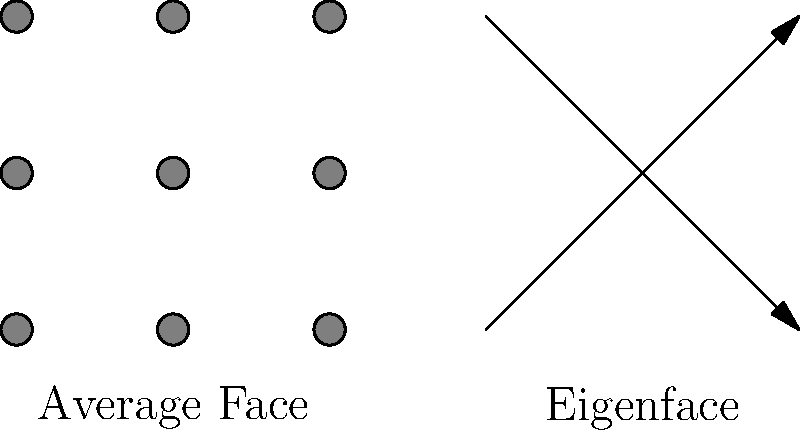In facial recognition using Principal Component Analysis (PCA), what does the eigenface represent in relation to the average face? To understand the concept of eigenfaces in facial recognition using PCA, let's break it down step-by-step:

1. Average Face:
   - The average face is computed by taking the mean of all face images in the dataset.
   - It represents the "typical" face and serves as a baseline for comparison.

2. PCA:
   - PCA is applied to the dataset of face images to find the principal components.
   - These components capture the most significant variations in the dataset.

3. Eigenfaces:
   - Eigenfaces are the eigenvectors of the covariance matrix of the face image dataset.
   - Each eigenface represents a direction of variation from the average face.
   - They are ordered by their corresponding eigenvalues, which indicate the amount of variance they capture.

4. Interpretation:
   - Eigenfaces can be thought of as the "building blocks" of faces.
   - They represent the most common ways in which faces in the dataset differ from the average face.
   - By combining these eigenfaces with different weights, we can reconstruct or approximate any face in the dataset.

5. Relation to Average Face:
   - Eigenfaces show how faces typically deviate from the average face.
   - They capture the patterns of variation that are most common across all faces in the dataset.

6. Use in Recognition:
   - Any face can be approximately represented as a weighted sum of the average face and the eigenfaces.
   - These weights form a compact representation of the face, which can be used for recognition tasks.

In the diagram, the average face is shown on the left, and a simplified representation of an eigenface is shown on the right. The arrows in the eigenface indicate directions of variation from the average face.
Answer: Directions of variation from the average face 